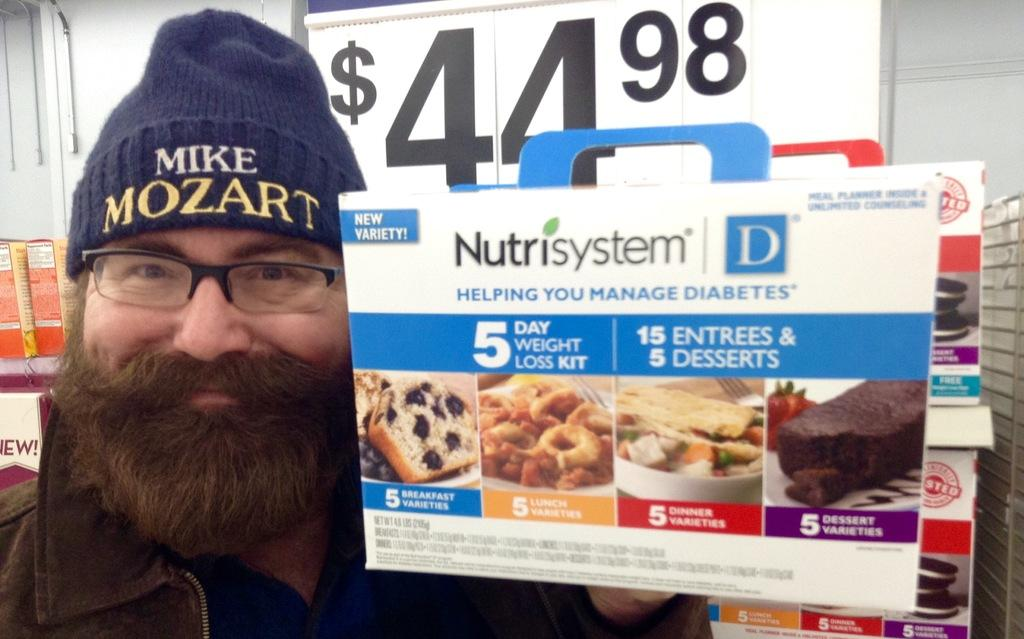Who is present in the image? There is a man in the image. What is the man wearing on his head? The man is wearing a cap. What accessory is the man wearing on his face? The man is wearing spectacles. What is the man holding in the image? The man is holding a banner. What is the color of the wall in the image? There is a white color wall in the image. What architectural feature can be seen in the image? There is a door in the image. What type of popcorn can be seen in the bag that the man is holding? There is no popcorn or bag present in the image. The man is holding a banner, not a bag. 